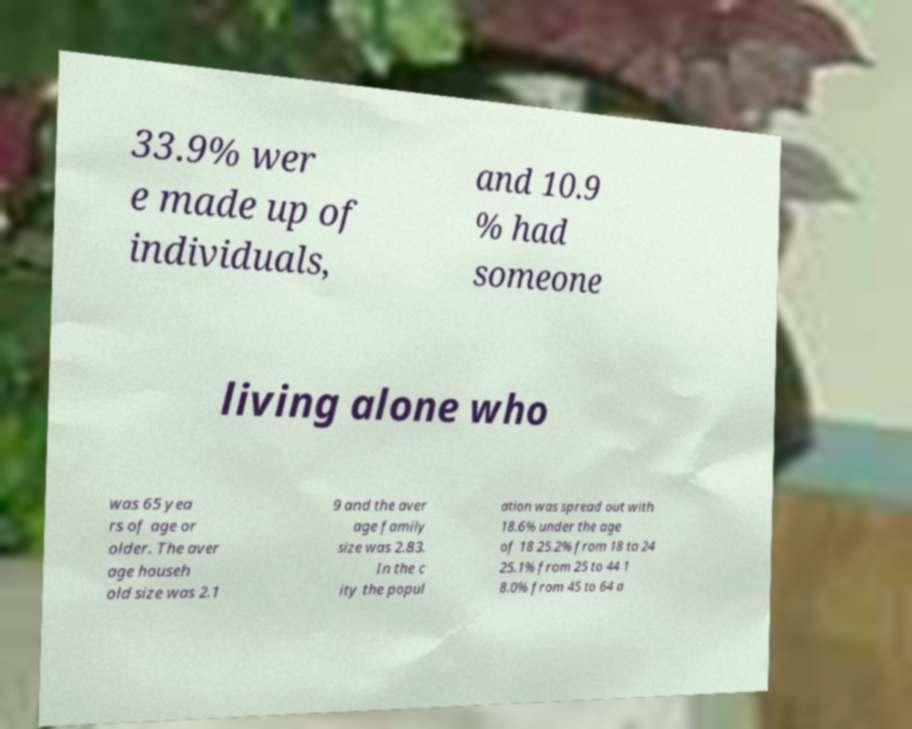There's text embedded in this image that I need extracted. Can you transcribe it verbatim? 33.9% wer e made up of individuals, and 10.9 % had someone living alone who was 65 yea rs of age or older. The aver age househ old size was 2.1 9 and the aver age family size was 2.83. In the c ity the popul ation was spread out with 18.6% under the age of 18 25.2% from 18 to 24 25.1% from 25 to 44 1 8.0% from 45 to 64 a 